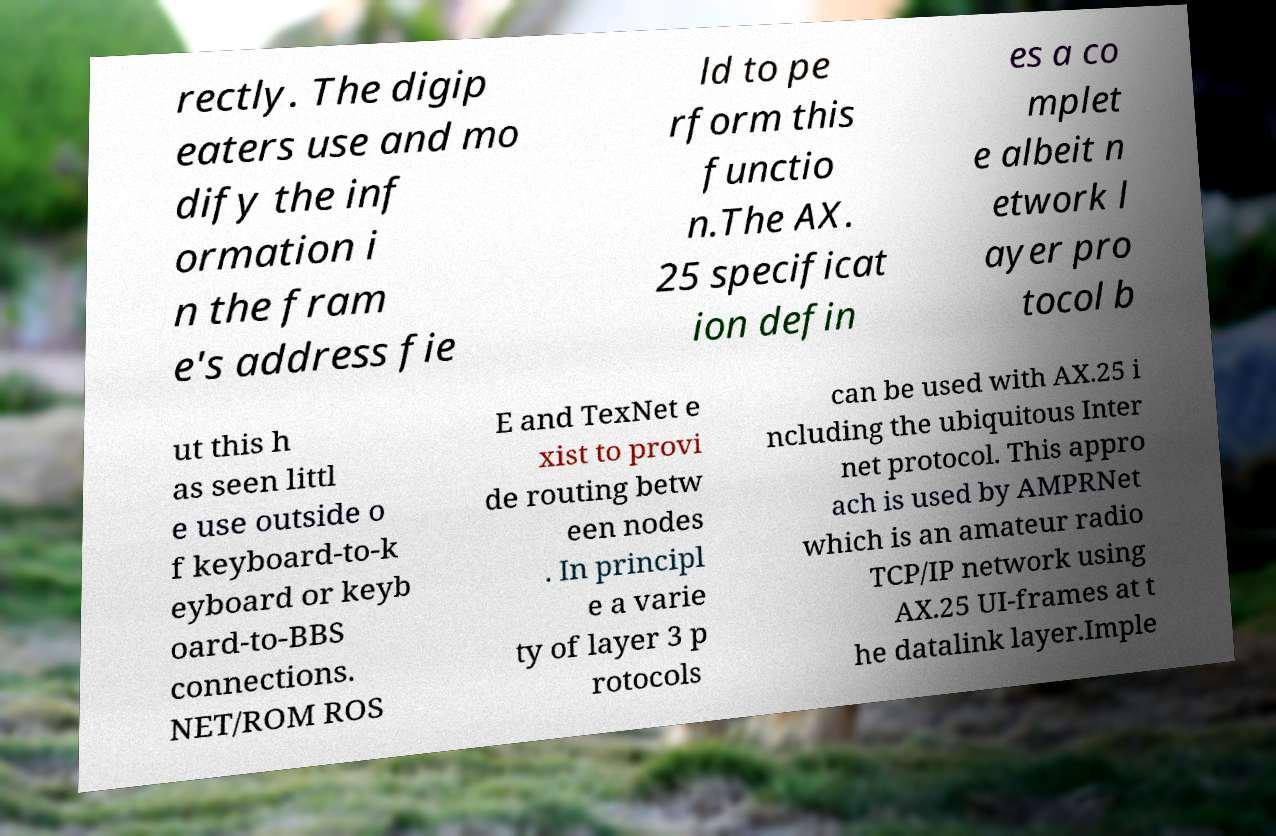Could you extract and type out the text from this image? rectly. The digip eaters use and mo dify the inf ormation i n the fram e's address fie ld to pe rform this functio n.The AX. 25 specificat ion defin es a co mplet e albeit n etwork l ayer pro tocol b ut this h as seen littl e use outside o f keyboard-to-k eyboard or keyb oard-to-BBS connections. NET/ROM ROS E and TexNet e xist to provi de routing betw een nodes . In principl e a varie ty of layer 3 p rotocols can be used with AX.25 i ncluding the ubiquitous Inter net protocol. This appro ach is used by AMPRNet which is an amateur radio TCP/IP network using AX.25 UI-frames at t he datalink layer.Imple 